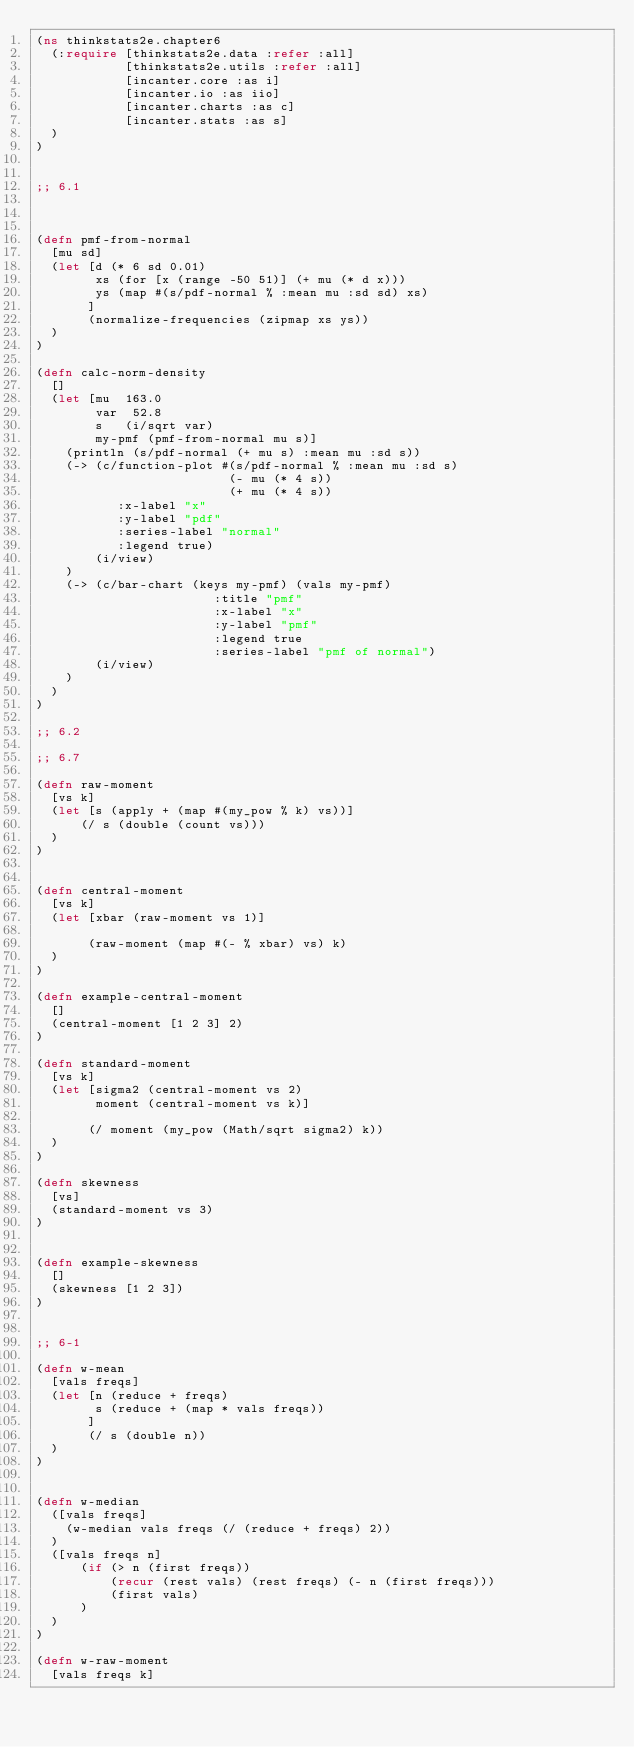Convert code to text. <code><loc_0><loc_0><loc_500><loc_500><_Clojure_>(ns thinkstats2e.chapter6
  (:require [thinkstats2e.data :refer :all]
            [thinkstats2e.utils :refer :all]
            [incanter.core :as i]
            [incanter.io :as iio]
            [incanter.charts :as c]
            [incanter.stats :as s]
  )
)


;; 6.1



(defn pmf-from-normal
  [mu sd]
  (let [d (* 6 sd 0.01)
        xs (for [x (range -50 51)] (+ mu (* d x)))      
        ys (map #(s/pdf-normal % :mean mu :sd sd) xs)
       ]
       (normalize-frequencies (zipmap xs ys))
  )
)

(defn calc-norm-density
  []
  (let [mu  163.0
        var  52.8
        s   (i/sqrt var)
        my-pmf (pmf-from-normal mu s)]
    (println (s/pdf-normal (+ mu s) :mean mu :sd s))
    (-> (c/function-plot #(s/pdf-normal % :mean mu :sd s) 
                          (- mu (* 4 s)) 
                          (+ mu (* 4 s))
           :x-label "x"
           :y-label "pdf"
           :series-label "normal"
           :legend true)
        (i/view)
    )
    (-> (c/bar-chart (keys my-pmf) (vals my-pmf) 
                        :title "pmf"
                        :x-label "x"
                        :y-label "pmf"
                        :legend true
                        :series-label "pmf of normal")
        (i/view)
    )
  )
)

;; 6.2

;; 6.7

(defn raw-moment 
  [vs k]
  (let [s (apply + (map #(my_pow % k) vs))]
      (/ s (double (count vs)))
  )
)


(defn central-moment 
  [vs k]
  (let [xbar (raw-moment vs 1)]
       
       (raw-moment (map #(- % xbar) vs) k)
  )
)

(defn example-central-moment
  []
  (central-moment [1 2 3] 2) 
)

(defn standard-moment 
  [vs k]
  (let [sigma2 (central-moment vs 2)
        moment (central-moment vs k)]
       
       (/ moment (my_pow (Math/sqrt sigma2) k))
  )
)

(defn skewness 
  [vs]
  (standard-moment vs 3)
)


(defn example-skewness
  []
  (skewness [1 2 3]) 
)


;; 6-1

(defn w-mean
  [vals freqs]
  (let [n (reduce + freqs)
        s (reduce + (map * vals freqs))
       ]
       (/ s (double n))  
  )
)


(defn w-median
  ([vals freqs]
    (w-median vals freqs (/ (reduce + freqs) 2))
  )
  ([vals freqs n]
      (if (> n (first freqs))
          (recur (rest vals) (rest freqs) (- n (first freqs))) 
          (first vals)    
      )
  )
)

(defn w-raw-moment
  [vals freqs k]</code> 